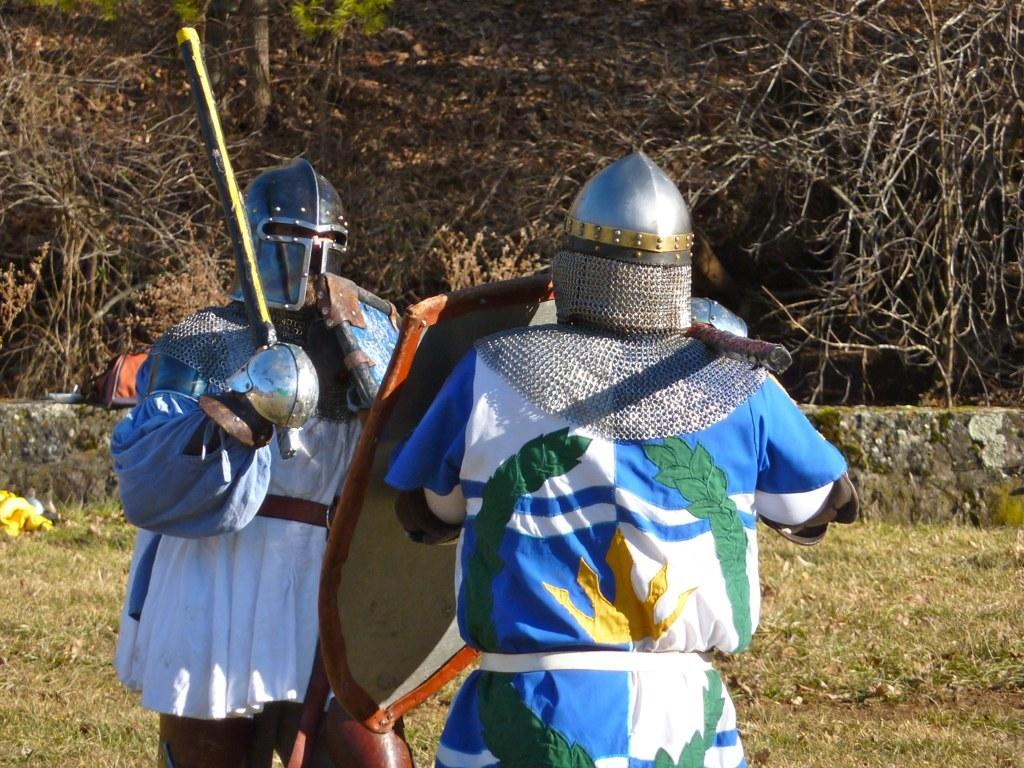How many people are in the image? There are two people standing in the image. What are the people wearing on their heads? The people are wearing helmets. What are the people holding in their hands? The people are holding objects in their hands. What type of vegetation can be seen in the image? There is grass visible in the image, as well as trees. What is the background of the image? There is a wall in the image, which serves as the background. What type of bag is the person on the left carrying in the image? There is no bag visible in the image; the people are wearing helmets and holding objects in their hands. What color is the suit worn by the person on the right in the image? There is no suit visible in the image; the people are wearing helmets and clothes, but no suits are mentioned in the provided facts. 